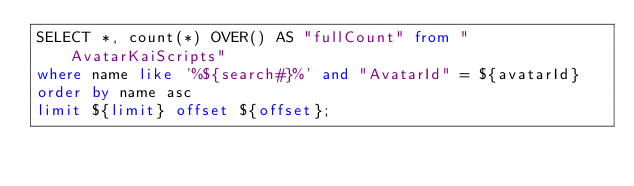Convert code to text. <code><loc_0><loc_0><loc_500><loc_500><_SQL_>SELECT *, count(*) OVER() AS "fullCount" from "AvatarKaiScripts"
where name like '%${search#}%' and "AvatarId" = ${avatarId}
order by name asc
limit ${limit} offset ${offset};
</code> 